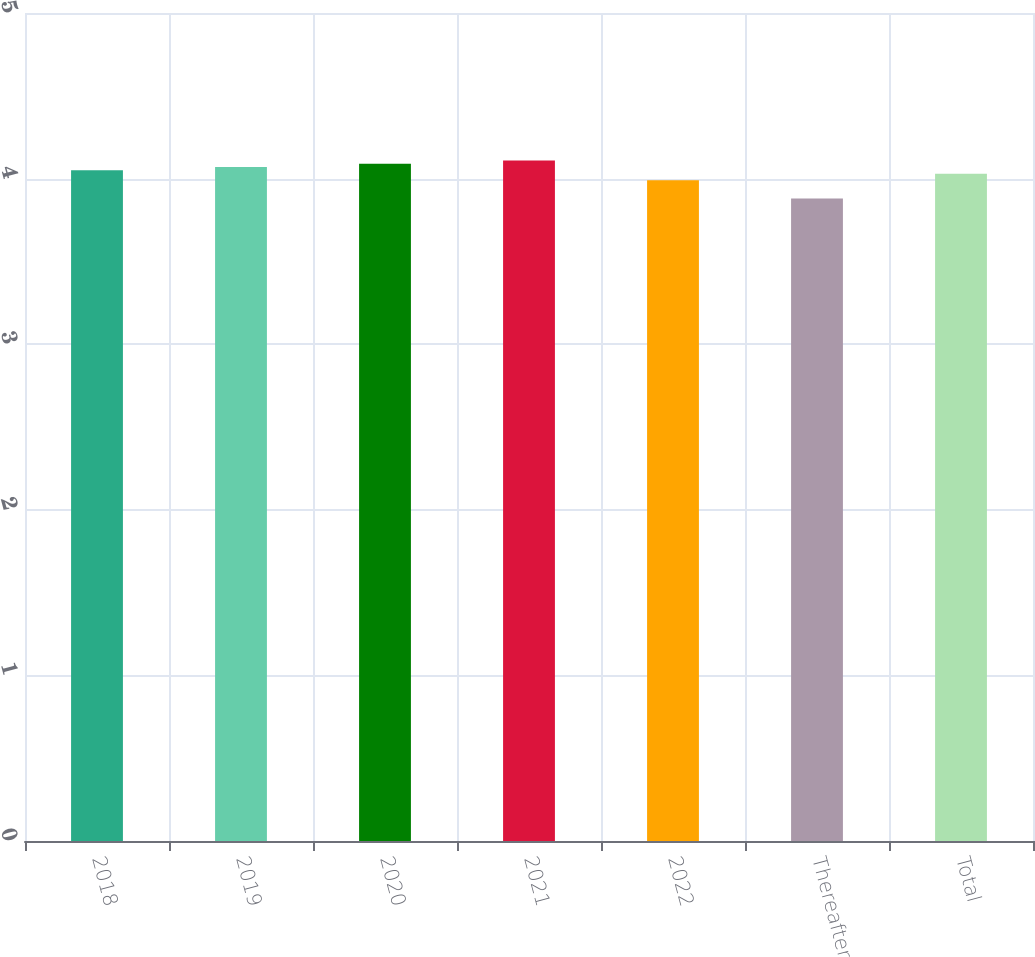<chart> <loc_0><loc_0><loc_500><loc_500><bar_chart><fcel>2018<fcel>2019<fcel>2020<fcel>2021<fcel>2022<fcel>Thereafter<fcel>Total<nl><fcel>4.05<fcel>4.07<fcel>4.09<fcel>4.11<fcel>3.99<fcel>3.88<fcel>4.03<nl></chart> 